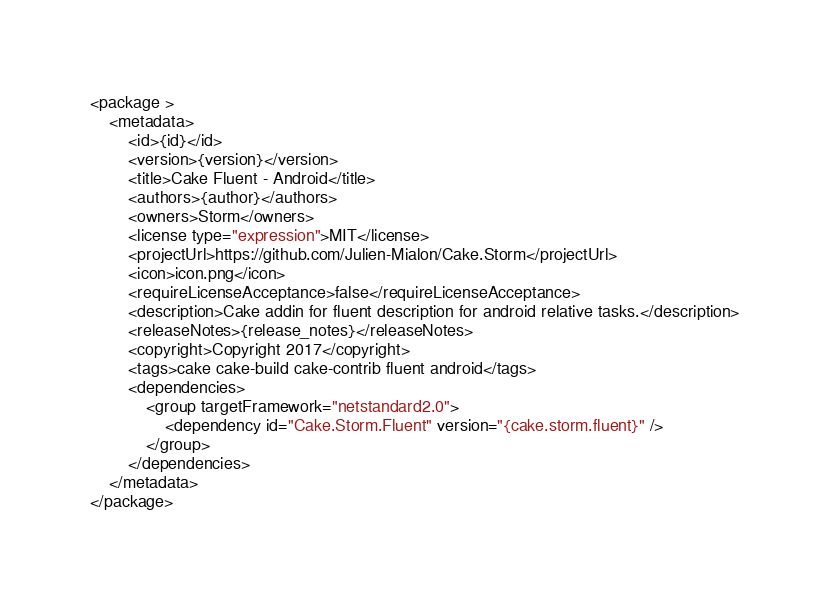<code> <loc_0><loc_0><loc_500><loc_500><_XML_><package >
	<metadata>
		<id>{id}</id>
		<version>{version}</version>
		<title>Cake Fluent - Android</title>
		<authors>{author}</authors>
		<owners>Storm</owners>
		<license type="expression">MIT</license>
		<projectUrl>https://github.com/Julien-Mialon/Cake.Storm</projectUrl>
		<icon>icon.png</icon>
		<requireLicenseAcceptance>false</requireLicenseAcceptance>
		<description>Cake addin for fluent description for android relative tasks.</description>
		<releaseNotes>{release_notes}</releaseNotes>
		<copyright>Copyright 2017</copyright>
		<tags>cake cake-build cake-contrib fluent android</tags>
		<dependencies>
			<group targetFramework="netstandard2.0">
				<dependency id="Cake.Storm.Fluent" version="{cake.storm.fluent}" />
			</group>
		</dependencies>
	</metadata>
</package></code> 